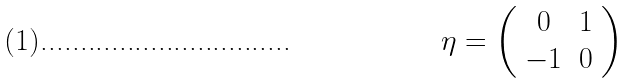Convert formula to latex. <formula><loc_0><loc_0><loc_500><loc_500>\eta = \left ( \begin{array} { c c } 0 & 1 \\ - 1 & 0 \end{array} \right )</formula> 